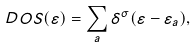<formula> <loc_0><loc_0><loc_500><loc_500>D O S ( \varepsilon ) = \sum _ { a } \delta ^ { \sigma } ( \varepsilon - \varepsilon _ { a } ) ,</formula> 